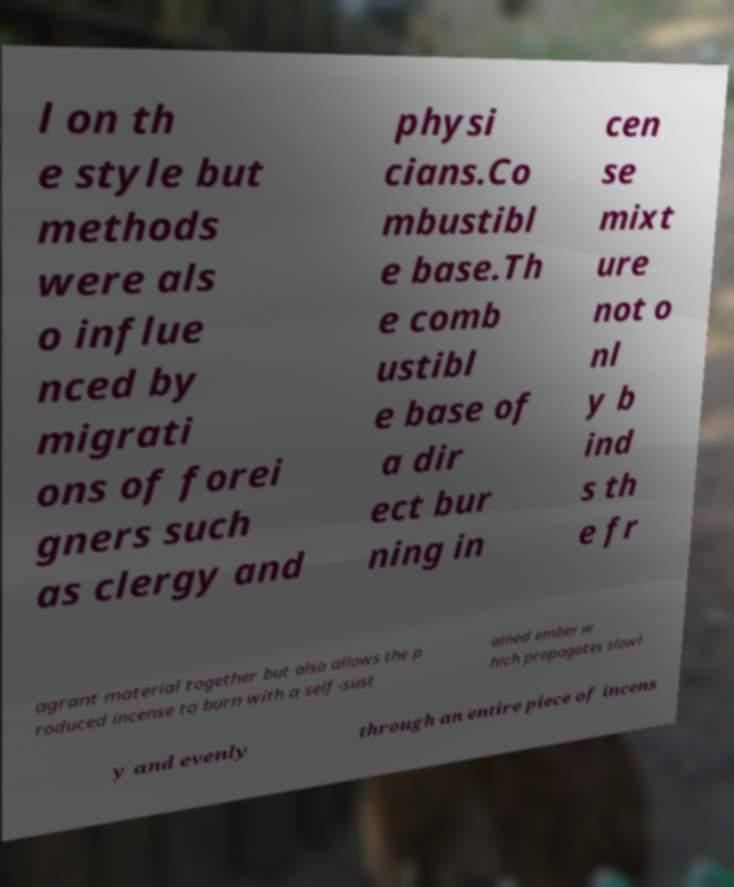For documentation purposes, I need the text within this image transcribed. Could you provide that? l on th e style but methods were als o influe nced by migrati ons of forei gners such as clergy and physi cians.Co mbustibl e base.Th e comb ustibl e base of a dir ect bur ning in cen se mixt ure not o nl y b ind s th e fr agrant material together but also allows the p roduced incense to burn with a self-sust ained ember w hich propagates slowl y and evenly through an entire piece of incens 